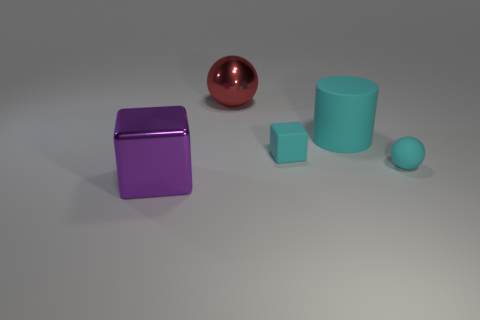There is a small matte thing that is in front of the tiny rubber cube; is its color the same as the small block?
Ensure brevity in your answer.  Yes. There is a object that is in front of the tiny cyan block and to the left of the small cube; what is its color?
Keep it short and to the point. Purple. Are there any cyan objects made of the same material as the large cyan cylinder?
Ensure brevity in your answer.  Yes. How big is the cyan cylinder?
Offer a very short reply. Large. What is the size of the block right of the metal object that is to the left of the big red thing?
Provide a short and direct response. Small. How many brown metallic cylinders are there?
Give a very brief answer. 0. What color is the sphere to the right of the rubber thing that is behind the matte cube that is on the right side of the red shiny ball?
Your answer should be compact. Cyan. Are there fewer large shiny cubes than small metallic cubes?
Offer a very short reply. No. There is a small matte object that is the same shape as the purple metallic thing; what is its color?
Make the answer very short. Cyan. What is the color of the thing that is made of the same material as the big red sphere?
Make the answer very short. Purple. 